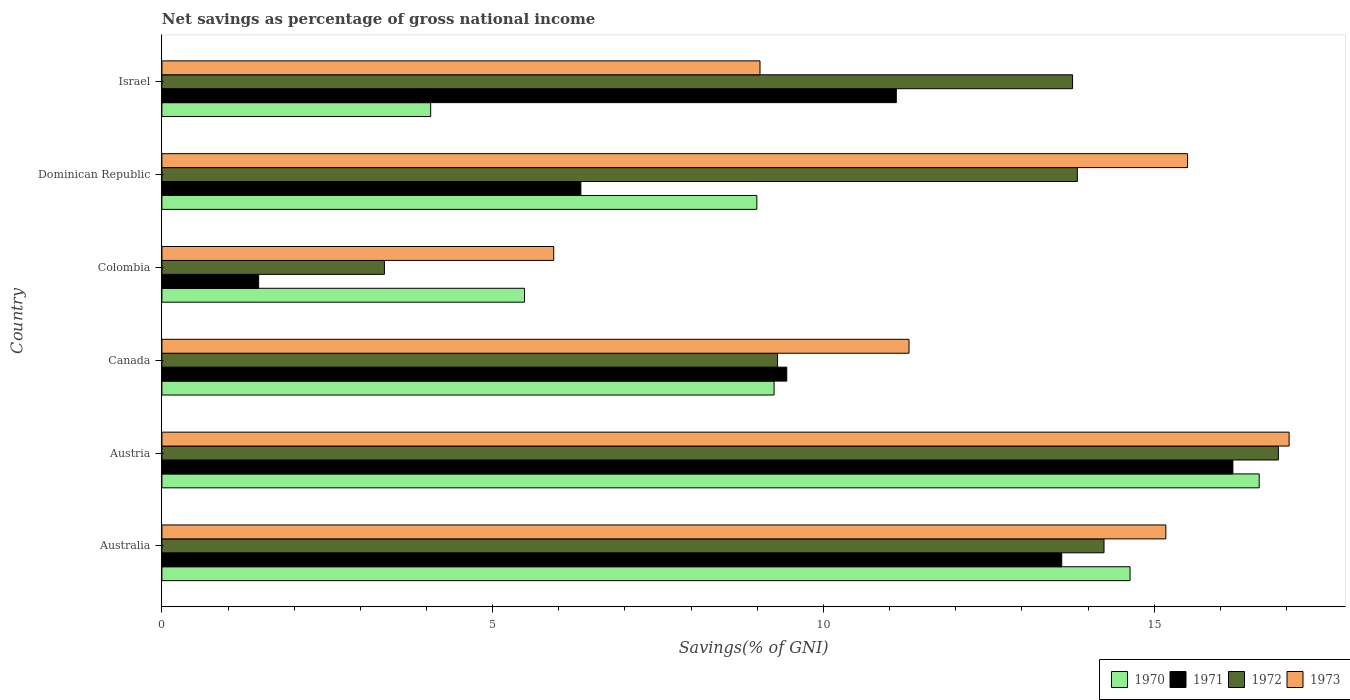Are the number of bars per tick equal to the number of legend labels?
Make the answer very short. Yes. Are the number of bars on each tick of the Y-axis equal?
Your answer should be compact. Yes. How many bars are there on the 6th tick from the top?
Your answer should be compact. 4. What is the label of the 6th group of bars from the top?
Your answer should be very brief. Australia. What is the total savings in 1970 in Dominican Republic?
Provide a succinct answer. 8.99. Across all countries, what is the maximum total savings in 1973?
Provide a succinct answer. 17.04. Across all countries, what is the minimum total savings in 1971?
Keep it short and to the point. 1.46. In which country was the total savings in 1970 minimum?
Offer a very short reply. Israel. What is the total total savings in 1970 in the graph?
Keep it short and to the point. 59.01. What is the difference between the total savings in 1970 in Canada and that in Israel?
Give a very brief answer. 5.19. What is the difference between the total savings in 1973 in Austria and the total savings in 1972 in Australia?
Make the answer very short. 2.8. What is the average total savings in 1970 per country?
Offer a terse response. 9.84. What is the difference between the total savings in 1972 and total savings in 1971 in Canada?
Keep it short and to the point. -0.14. In how many countries, is the total savings in 1973 greater than 6 %?
Ensure brevity in your answer.  5. What is the ratio of the total savings in 1970 in Austria to that in Colombia?
Keep it short and to the point. 3.03. Is the difference between the total savings in 1972 in Colombia and Dominican Republic greater than the difference between the total savings in 1971 in Colombia and Dominican Republic?
Ensure brevity in your answer.  No. What is the difference between the highest and the second highest total savings in 1971?
Provide a succinct answer. 2.59. What is the difference between the highest and the lowest total savings in 1971?
Offer a very short reply. 14.73. In how many countries, is the total savings in 1970 greater than the average total savings in 1970 taken over all countries?
Provide a succinct answer. 2. Is it the case that in every country, the sum of the total savings in 1970 and total savings in 1972 is greater than the sum of total savings in 1971 and total savings in 1973?
Give a very brief answer. Yes. What does the 3rd bar from the top in Dominican Republic represents?
Provide a short and direct response. 1971. What does the 3rd bar from the bottom in Israel represents?
Offer a very short reply. 1972. Are all the bars in the graph horizontal?
Ensure brevity in your answer.  Yes. Are the values on the major ticks of X-axis written in scientific E-notation?
Make the answer very short. No. Where does the legend appear in the graph?
Offer a terse response. Bottom right. How are the legend labels stacked?
Offer a very short reply. Horizontal. What is the title of the graph?
Give a very brief answer. Net savings as percentage of gross national income. Does "1993" appear as one of the legend labels in the graph?
Keep it short and to the point. No. What is the label or title of the X-axis?
Your answer should be compact. Savings(% of GNI). What is the Savings(% of GNI) in 1970 in Australia?
Your response must be concise. 14.63. What is the Savings(% of GNI) in 1971 in Australia?
Keep it short and to the point. 13.6. What is the Savings(% of GNI) in 1972 in Australia?
Make the answer very short. 14.24. What is the Savings(% of GNI) in 1973 in Australia?
Offer a terse response. 15.18. What is the Savings(% of GNI) in 1970 in Austria?
Provide a succinct answer. 16.59. What is the Savings(% of GNI) of 1971 in Austria?
Provide a short and direct response. 16.19. What is the Savings(% of GNI) in 1972 in Austria?
Your answer should be compact. 16.88. What is the Savings(% of GNI) in 1973 in Austria?
Your answer should be compact. 17.04. What is the Savings(% of GNI) of 1970 in Canada?
Make the answer very short. 9.25. What is the Savings(% of GNI) in 1971 in Canada?
Your response must be concise. 9.45. What is the Savings(% of GNI) in 1972 in Canada?
Your answer should be very brief. 9.31. What is the Savings(% of GNI) of 1973 in Canada?
Provide a succinct answer. 11.29. What is the Savings(% of GNI) of 1970 in Colombia?
Offer a very short reply. 5.48. What is the Savings(% of GNI) of 1971 in Colombia?
Ensure brevity in your answer.  1.46. What is the Savings(% of GNI) in 1972 in Colombia?
Provide a short and direct response. 3.36. What is the Savings(% of GNI) of 1973 in Colombia?
Offer a very short reply. 5.92. What is the Savings(% of GNI) of 1970 in Dominican Republic?
Offer a very short reply. 8.99. What is the Savings(% of GNI) of 1971 in Dominican Republic?
Keep it short and to the point. 6.33. What is the Savings(% of GNI) of 1972 in Dominican Republic?
Provide a succinct answer. 13.84. What is the Savings(% of GNI) of 1973 in Dominican Republic?
Keep it short and to the point. 15.5. What is the Savings(% of GNI) of 1970 in Israel?
Your answer should be compact. 4.06. What is the Savings(% of GNI) in 1971 in Israel?
Keep it short and to the point. 11.1. What is the Savings(% of GNI) of 1972 in Israel?
Make the answer very short. 13.77. What is the Savings(% of GNI) of 1973 in Israel?
Your answer should be compact. 9.04. Across all countries, what is the maximum Savings(% of GNI) in 1970?
Ensure brevity in your answer.  16.59. Across all countries, what is the maximum Savings(% of GNI) in 1971?
Offer a very short reply. 16.19. Across all countries, what is the maximum Savings(% of GNI) in 1972?
Offer a very short reply. 16.88. Across all countries, what is the maximum Savings(% of GNI) of 1973?
Your answer should be very brief. 17.04. Across all countries, what is the minimum Savings(% of GNI) in 1970?
Provide a succinct answer. 4.06. Across all countries, what is the minimum Savings(% of GNI) in 1971?
Ensure brevity in your answer.  1.46. Across all countries, what is the minimum Savings(% of GNI) in 1972?
Keep it short and to the point. 3.36. Across all countries, what is the minimum Savings(% of GNI) in 1973?
Offer a very short reply. 5.92. What is the total Savings(% of GNI) in 1970 in the graph?
Provide a short and direct response. 59.01. What is the total Savings(% of GNI) in 1971 in the graph?
Your answer should be compact. 58.14. What is the total Savings(% of GNI) in 1972 in the graph?
Ensure brevity in your answer.  71.39. What is the total Savings(% of GNI) in 1973 in the graph?
Give a very brief answer. 73.98. What is the difference between the Savings(% of GNI) of 1970 in Australia and that in Austria?
Provide a short and direct response. -1.95. What is the difference between the Savings(% of GNI) in 1971 in Australia and that in Austria?
Make the answer very short. -2.59. What is the difference between the Savings(% of GNI) in 1972 in Australia and that in Austria?
Make the answer very short. -2.64. What is the difference between the Savings(% of GNI) of 1973 in Australia and that in Austria?
Keep it short and to the point. -1.86. What is the difference between the Savings(% of GNI) in 1970 in Australia and that in Canada?
Offer a terse response. 5.38. What is the difference between the Savings(% of GNI) of 1971 in Australia and that in Canada?
Make the answer very short. 4.16. What is the difference between the Savings(% of GNI) in 1972 in Australia and that in Canada?
Your answer should be very brief. 4.93. What is the difference between the Savings(% of GNI) of 1973 in Australia and that in Canada?
Your answer should be compact. 3.88. What is the difference between the Savings(% of GNI) of 1970 in Australia and that in Colombia?
Offer a terse response. 9.15. What is the difference between the Savings(% of GNI) in 1971 in Australia and that in Colombia?
Provide a short and direct response. 12.14. What is the difference between the Savings(% of GNI) in 1972 in Australia and that in Colombia?
Offer a very short reply. 10.88. What is the difference between the Savings(% of GNI) in 1973 in Australia and that in Colombia?
Offer a terse response. 9.25. What is the difference between the Savings(% of GNI) of 1970 in Australia and that in Dominican Republic?
Offer a terse response. 5.64. What is the difference between the Savings(% of GNI) in 1971 in Australia and that in Dominican Republic?
Offer a very short reply. 7.27. What is the difference between the Savings(% of GNI) of 1972 in Australia and that in Dominican Republic?
Ensure brevity in your answer.  0.4. What is the difference between the Savings(% of GNI) of 1973 in Australia and that in Dominican Republic?
Your response must be concise. -0.33. What is the difference between the Savings(% of GNI) in 1970 in Australia and that in Israel?
Keep it short and to the point. 10.57. What is the difference between the Savings(% of GNI) in 1971 in Australia and that in Israel?
Provide a succinct answer. 2.5. What is the difference between the Savings(% of GNI) in 1972 in Australia and that in Israel?
Ensure brevity in your answer.  0.48. What is the difference between the Savings(% of GNI) of 1973 in Australia and that in Israel?
Provide a succinct answer. 6.14. What is the difference between the Savings(% of GNI) in 1970 in Austria and that in Canada?
Offer a terse response. 7.33. What is the difference between the Savings(% of GNI) in 1971 in Austria and that in Canada?
Give a very brief answer. 6.74. What is the difference between the Savings(% of GNI) of 1972 in Austria and that in Canada?
Make the answer very short. 7.57. What is the difference between the Savings(% of GNI) of 1973 in Austria and that in Canada?
Your answer should be very brief. 5.75. What is the difference between the Savings(% of GNI) of 1970 in Austria and that in Colombia?
Give a very brief answer. 11.11. What is the difference between the Savings(% of GNI) in 1971 in Austria and that in Colombia?
Ensure brevity in your answer.  14.73. What is the difference between the Savings(% of GNI) of 1972 in Austria and that in Colombia?
Your answer should be compact. 13.51. What is the difference between the Savings(% of GNI) of 1973 in Austria and that in Colombia?
Provide a succinct answer. 11.12. What is the difference between the Savings(% of GNI) of 1970 in Austria and that in Dominican Republic?
Keep it short and to the point. 7.59. What is the difference between the Savings(% of GNI) in 1971 in Austria and that in Dominican Republic?
Give a very brief answer. 9.86. What is the difference between the Savings(% of GNI) in 1972 in Austria and that in Dominican Republic?
Make the answer very short. 3.04. What is the difference between the Savings(% of GNI) in 1973 in Austria and that in Dominican Republic?
Offer a terse response. 1.54. What is the difference between the Savings(% of GNI) in 1970 in Austria and that in Israel?
Provide a short and direct response. 12.52. What is the difference between the Savings(% of GNI) of 1971 in Austria and that in Israel?
Keep it short and to the point. 5.09. What is the difference between the Savings(% of GNI) of 1972 in Austria and that in Israel?
Give a very brief answer. 3.11. What is the difference between the Savings(% of GNI) of 1973 in Austria and that in Israel?
Give a very brief answer. 8. What is the difference between the Savings(% of GNI) in 1970 in Canada and that in Colombia?
Ensure brevity in your answer.  3.77. What is the difference between the Savings(% of GNI) of 1971 in Canada and that in Colombia?
Offer a very short reply. 7.98. What is the difference between the Savings(% of GNI) of 1972 in Canada and that in Colombia?
Ensure brevity in your answer.  5.94. What is the difference between the Savings(% of GNI) in 1973 in Canada and that in Colombia?
Ensure brevity in your answer.  5.37. What is the difference between the Savings(% of GNI) of 1970 in Canada and that in Dominican Republic?
Provide a short and direct response. 0.26. What is the difference between the Savings(% of GNI) of 1971 in Canada and that in Dominican Republic?
Provide a short and direct response. 3.11. What is the difference between the Savings(% of GNI) in 1972 in Canada and that in Dominican Republic?
Your answer should be compact. -4.53. What is the difference between the Savings(% of GNI) of 1973 in Canada and that in Dominican Republic?
Ensure brevity in your answer.  -4.21. What is the difference between the Savings(% of GNI) in 1970 in Canada and that in Israel?
Offer a very short reply. 5.19. What is the difference between the Savings(% of GNI) of 1971 in Canada and that in Israel?
Provide a succinct answer. -1.66. What is the difference between the Savings(% of GNI) of 1972 in Canada and that in Israel?
Offer a very short reply. -4.46. What is the difference between the Savings(% of GNI) in 1973 in Canada and that in Israel?
Offer a terse response. 2.25. What is the difference between the Savings(% of GNI) of 1970 in Colombia and that in Dominican Republic?
Keep it short and to the point. -3.51. What is the difference between the Savings(% of GNI) in 1971 in Colombia and that in Dominican Republic?
Offer a very short reply. -4.87. What is the difference between the Savings(% of GNI) of 1972 in Colombia and that in Dominican Republic?
Your answer should be very brief. -10.47. What is the difference between the Savings(% of GNI) of 1973 in Colombia and that in Dominican Republic?
Your response must be concise. -9.58. What is the difference between the Savings(% of GNI) in 1970 in Colombia and that in Israel?
Ensure brevity in your answer.  1.42. What is the difference between the Savings(% of GNI) in 1971 in Colombia and that in Israel?
Make the answer very short. -9.64. What is the difference between the Savings(% of GNI) in 1972 in Colombia and that in Israel?
Provide a succinct answer. -10.4. What is the difference between the Savings(% of GNI) of 1973 in Colombia and that in Israel?
Make the answer very short. -3.12. What is the difference between the Savings(% of GNI) in 1970 in Dominican Republic and that in Israel?
Make the answer very short. 4.93. What is the difference between the Savings(% of GNI) of 1971 in Dominican Republic and that in Israel?
Keep it short and to the point. -4.77. What is the difference between the Savings(% of GNI) of 1972 in Dominican Republic and that in Israel?
Your answer should be very brief. 0.07. What is the difference between the Savings(% of GNI) of 1973 in Dominican Republic and that in Israel?
Give a very brief answer. 6.46. What is the difference between the Savings(% of GNI) in 1970 in Australia and the Savings(% of GNI) in 1971 in Austria?
Your answer should be very brief. -1.55. What is the difference between the Savings(% of GNI) in 1970 in Australia and the Savings(% of GNI) in 1972 in Austria?
Give a very brief answer. -2.24. What is the difference between the Savings(% of GNI) in 1970 in Australia and the Savings(% of GNI) in 1973 in Austria?
Provide a succinct answer. -2.4. What is the difference between the Savings(% of GNI) in 1971 in Australia and the Savings(% of GNI) in 1972 in Austria?
Make the answer very short. -3.27. What is the difference between the Savings(% of GNI) of 1971 in Australia and the Savings(% of GNI) of 1973 in Austria?
Offer a very short reply. -3.44. What is the difference between the Savings(% of GNI) in 1972 in Australia and the Savings(% of GNI) in 1973 in Austria?
Keep it short and to the point. -2.8. What is the difference between the Savings(% of GNI) in 1970 in Australia and the Savings(% of GNI) in 1971 in Canada?
Your answer should be very brief. 5.19. What is the difference between the Savings(% of GNI) in 1970 in Australia and the Savings(% of GNI) in 1972 in Canada?
Your answer should be very brief. 5.33. What is the difference between the Savings(% of GNI) of 1970 in Australia and the Savings(% of GNI) of 1973 in Canada?
Provide a succinct answer. 3.34. What is the difference between the Savings(% of GNI) of 1971 in Australia and the Savings(% of GNI) of 1972 in Canada?
Make the answer very short. 4.3. What is the difference between the Savings(% of GNI) in 1971 in Australia and the Savings(% of GNI) in 1973 in Canada?
Provide a short and direct response. 2.31. What is the difference between the Savings(% of GNI) of 1972 in Australia and the Savings(% of GNI) of 1973 in Canada?
Provide a succinct answer. 2.95. What is the difference between the Savings(% of GNI) in 1970 in Australia and the Savings(% of GNI) in 1971 in Colombia?
Make the answer very short. 13.17. What is the difference between the Savings(% of GNI) of 1970 in Australia and the Savings(% of GNI) of 1972 in Colombia?
Offer a terse response. 11.27. What is the difference between the Savings(% of GNI) in 1970 in Australia and the Savings(% of GNI) in 1973 in Colombia?
Make the answer very short. 8.71. What is the difference between the Savings(% of GNI) in 1971 in Australia and the Savings(% of GNI) in 1972 in Colombia?
Provide a short and direct response. 10.24. What is the difference between the Savings(% of GNI) of 1971 in Australia and the Savings(% of GNI) of 1973 in Colombia?
Offer a terse response. 7.68. What is the difference between the Savings(% of GNI) in 1972 in Australia and the Savings(% of GNI) in 1973 in Colombia?
Provide a succinct answer. 8.32. What is the difference between the Savings(% of GNI) of 1970 in Australia and the Savings(% of GNI) of 1971 in Dominican Republic?
Your answer should be compact. 8.3. What is the difference between the Savings(% of GNI) in 1970 in Australia and the Savings(% of GNI) in 1972 in Dominican Republic?
Give a very brief answer. 0.8. What is the difference between the Savings(% of GNI) in 1970 in Australia and the Savings(% of GNI) in 1973 in Dominican Republic?
Offer a terse response. -0.87. What is the difference between the Savings(% of GNI) of 1971 in Australia and the Savings(% of GNI) of 1972 in Dominican Republic?
Provide a succinct answer. -0.24. What is the difference between the Savings(% of GNI) of 1971 in Australia and the Savings(% of GNI) of 1973 in Dominican Republic?
Give a very brief answer. -1.9. What is the difference between the Savings(% of GNI) in 1972 in Australia and the Savings(% of GNI) in 1973 in Dominican Republic?
Your answer should be compact. -1.26. What is the difference between the Savings(% of GNI) of 1970 in Australia and the Savings(% of GNI) of 1971 in Israel?
Provide a succinct answer. 3.53. What is the difference between the Savings(% of GNI) of 1970 in Australia and the Savings(% of GNI) of 1972 in Israel?
Your answer should be very brief. 0.87. What is the difference between the Savings(% of GNI) in 1970 in Australia and the Savings(% of GNI) in 1973 in Israel?
Provide a succinct answer. 5.59. What is the difference between the Savings(% of GNI) of 1971 in Australia and the Savings(% of GNI) of 1972 in Israel?
Make the answer very short. -0.16. What is the difference between the Savings(% of GNI) of 1971 in Australia and the Savings(% of GNI) of 1973 in Israel?
Your answer should be very brief. 4.56. What is the difference between the Savings(% of GNI) of 1972 in Australia and the Savings(% of GNI) of 1973 in Israel?
Offer a very short reply. 5.2. What is the difference between the Savings(% of GNI) in 1970 in Austria and the Savings(% of GNI) in 1971 in Canada?
Your answer should be compact. 7.14. What is the difference between the Savings(% of GNI) in 1970 in Austria and the Savings(% of GNI) in 1972 in Canada?
Offer a very short reply. 7.28. What is the difference between the Savings(% of GNI) of 1970 in Austria and the Savings(% of GNI) of 1973 in Canada?
Your answer should be compact. 5.29. What is the difference between the Savings(% of GNI) of 1971 in Austria and the Savings(% of GNI) of 1972 in Canada?
Your answer should be compact. 6.88. What is the difference between the Savings(% of GNI) of 1971 in Austria and the Savings(% of GNI) of 1973 in Canada?
Give a very brief answer. 4.9. What is the difference between the Savings(% of GNI) in 1972 in Austria and the Savings(% of GNI) in 1973 in Canada?
Your answer should be compact. 5.58. What is the difference between the Savings(% of GNI) in 1970 in Austria and the Savings(% of GNI) in 1971 in Colombia?
Provide a succinct answer. 15.12. What is the difference between the Savings(% of GNI) in 1970 in Austria and the Savings(% of GNI) in 1972 in Colombia?
Give a very brief answer. 13.22. What is the difference between the Savings(% of GNI) of 1970 in Austria and the Savings(% of GNI) of 1973 in Colombia?
Provide a succinct answer. 10.66. What is the difference between the Savings(% of GNI) of 1971 in Austria and the Savings(% of GNI) of 1972 in Colombia?
Offer a terse response. 12.83. What is the difference between the Savings(% of GNI) of 1971 in Austria and the Savings(% of GNI) of 1973 in Colombia?
Ensure brevity in your answer.  10.27. What is the difference between the Savings(% of GNI) of 1972 in Austria and the Savings(% of GNI) of 1973 in Colombia?
Your response must be concise. 10.95. What is the difference between the Savings(% of GNI) of 1970 in Austria and the Savings(% of GNI) of 1971 in Dominican Republic?
Make the answer very short. 10.25. What is the difference between the Savings(% of GNI) of 1970 in Austria and the Savings(% of GNI) of 1972 in Dominican Republic?
Provide a short and direct response. 2.75. What is the difference between the Savings(% of GNI) in 1970 in Austria and the Savings(% of GNI) in 1973 in Dominican Republic?
Your response must be concise. 1.08. What is the difference between the Savings(% of GNI) in 1971 in Austria and the Savings(% of GNI) in 1972 in Dominican Republic?
Give a very brief answer. 2.35. What is the difference between the Savings(% of GNI) in 1971 in Austria and the Savings(% of GNI) in 1973 in Dominican Republic?
Offer a very short reply. 0.69. What is the difference between the Savings(% of GNI) of 1972 in Austria and the Savings(% of GNI) of 1973 in Dominican Republic?
Make the answer very short. 1.37. What is the difference between the Savings(% of GNI) in 1970 in Austria and the Savings(% of GNI) in 1971 in Israel?
Provide a short and direct response. 5.49. What is the difference between the Savings(% of GNI) in 1970 in Austria and the Savings(% of GNI) in 1972 in Israel?
Offer a terse response. 2.82. What is the difference between the Savings(% of GNI) in 1970 in Austria and the Savings(% of GNI) in 1973 in Israel?
Offer a terse response. 7.55. What is the difference between the Savings(% of GNI) of 1971 in Austria and the Savings(% of GNI) of 1972 in Israel?
Your answer should be compact. 2.42. What is the difference between the Savings(% of GNI) of 1971 in Austria and the Savings(% of GNI) of 1973 in Israel?
Make the answer very short. 7.15. What is the difference between the Savings(% of GNI) of 1972 in Austria and the Savings(% of GNI) of 1973 in Israel?
Your answer should be very brief. 7.84. What is the difference between the Savings(% of GNI) in 1970 in Canada and the Savings(% of GNI) in 1971 in Colombia?
Ensure brevity in your answer.  7.79. What is the difference between the Savings(% of GNI) in 1970 in Canada and the Savings(% of GNI) in 1972 in Colombia?
Provide a succinct answer. 5.89. What is the difference between the Savings(% of GNI) in 1970 in Canada and the Savings(% of GNI) in 1973 in Colombia?
Offer a very short reply. 3.33. What is the difference between the Savings(% of GNI) of 1971 in Canada and the Savings(% of GNI) of 1972 in Colombia?
Make the answer very short. 6.08. What is the difference between the Savings(% of GNI) in 1971 in Canada and the Savings(% of GNI) in 1973 in Colombia?
Provide a succinct answer. 3.52. What is the difference between the Savings(% of GNI) of 1972 in Canada and the Savings(% of GNI) of 1973 in Colombia?
Offer a terse response. 3.38. What is the difference between the Savings(% of GNI) of 1970 in Canada and the Savings(% of GNI) of 1971 in Dominican Republic?
Your response must be concise. 2.92. What is the difference between the Savings(% of GNI) of 1970 in Canada and the Savings(% of GNI) of 1972 in Dominican Republic?
Keep it short and to the point. -4.58. What is the difference between the Savings(% of GNI) in 1970 in Canada and the Savings(% of GNI) in 1973 in Dominican Republic?
Provide a succinct answer. -6.25. What is the difference between the Savings(% of GNI) in 1971 in Canada and the Savings(% of GNI) in 1972 in Dominican Republic?
Ensure brevity in your answer.  -4.39. What is the difference between the Savings(% of GNI) in 1971 in Canada and the Savings(% of GNI) in 1973 in Dominican Republic?
Provide a short and direct response. -6.06. What is the difference between the Savings(% of GNI) in 1972 in Canada and the Savings(% of GNI) in 1973 in Dominican Republic?
Provide a succinct answer. -6.2. What is the difference between the Savings(% of GNI) of 1970 in Canada and the Savings(% of GNI) of 1971 in Israel?
Offer a terse response. -1.85. What is the difference between the Savings(% of GNI) in 1970 in Canada and the Savings(% of GNI) in 1972 in Israel?
Keep it short and to the point. -4.51. What is the difference between the Savings(% of GNI) in 1970 in Canada and the Savings(% of GNI) in 1973 in Israel?
Keep it short and to the point. 0.21. What is the difference between the Savings(% of GNI) of 1971 in Canada and the Savings(% of GNI) of 1972 in Israel?
Your answer should be very brief. -4.32. What is the difference between the Savings(% of GNI) in 1971 in Canada and the Savings(% of GNI) in 1973 in Israel?
Your answer should be compact. 0.4. What is the difference between the Savings(% of GNI) of 1972 in Canada and the Savings(% of GNI) of 1973 in Israel?
Ensure brevity in your answer.  0.27. What is the difference between the Savings(% of GNI) in 1970 in Colombia and the Savings(% of GNI) in 1971 in Dominican Republic?
Your answer should be very brief. -0.85. What is the difference between the Savings(% of GNI) in 1970 in Colombia and the Savings(% of GNI) in 1972 in Dominican Republic?
Offer a terse response. -8.36. What is the difference between the Savings(% of GNI) in 1970 in Colombia and the Savings(% of GNI) in 1973 in Dominican Republic?
Ensure brevity in your answer.  -10.02. What is the difference between the Savings(% of GNI) of 1971 in Colombia and the Savings(% of GNI) of 1972 in Dominican Republic?
Your answer should be compact. -12.38. What is the difference between the Savings(% of GNI) of 1971 in Colombia and the Savings(% of GNI) of 1973 in Dominican Republic?
Your answer should be very brief. -14.04. What is the difference between the Savings(% of GNI) in 1972 in Colombia and the Savings(% of GNI) in 1973 in Dominican Republic?
Your answer should be very brief. -12.14. What is the difference between the Savings(% of GNI) of 1970 in Colombia and the Savings(% of GNI) of 1971 in Israel?
Your answer should be very brief. -5.62. What is the difference between the Savings(% of GNI) of 1970 in Colombia and the Savings(% of GNI) of 1972 in Israel?
Give a very brief answer. -8.28. What is the difference between the Savings(% of GNI) of 1970 in Colombia and the Savings(% of GNI) of 1973 in Israel?
Your answer should be compact. -3.56. What is the difference between the Savings(% of GNI) of 1971 in Colombia and the Savings(% of GNI) of 1972 in Israel?
Ensure brevity in your answer.  -12.3. What is the difference between the Savings(% of GNI) of 1971 in Colombia and the Savings(% of GNI) of 1973 in Israel?
Your response must be concise. -7.58. What is the difference between the Savings(% of GNI) of 1972 in Colombia and the Savings(% of GNI) of 1973 in Israel?
Offer a very short reply. -5.68. What is the difference between the Savings(% of GNI) of 1970 in Dominican Republic and the Savings(% of GNI) of 1971 in Israel?
Provide a succinct answer. -2.11. What is the difference between the Savings(% of GNI) in 1970 in Dominican Republic and the Savings(% of GNI) in 1972 in Israel?
Give a very brief answer. -4.77. What is the difference between the Savings(% of GNI) of 1970 in Dominican Republic and the Savings(% of GNI) of 1973 in Israel?
Provide a succinct answer. -0.05. What is the difference between the Savings(% of GNI) of 1971 in Dominican Republic and the Savings(% of GNI) of 1972 in Israel?
Offer a terse response. -7.43. What is the difference between the Savings(% of GNI) of 1971 in Dominican Republic and the Savings(% of GNI) of 1973 in Israel?
Offer a terse response. -2.71. What is the difference between the Savings(% of GNI) of 1972 in Dominican Republic and the Savings(% of GNI) of 1973 in Israel?
Give a very brief answer. 4.8. What is the average Savings(% of GNI) of 1970 per country?
Give a very brief answer. 9.84. What is the average Savings(% of GNI) in 1971 per country?
Ensure brevity in your answer.  9.69. What is the average Savings(% of GNI) of 1972 per country?
Your answer should be very brief. 11.9. What is the average Savings(% of GNI) in 1973 per country?
Offer a terse response. 12.33. What is the difference between the Savings(% of GNI) in 1970 and Savings(% of GNI) in 1971 in Australia?
Provide a short and direct response. 1.03. What is the difference between the Savings(% of GNI) in 1970 and Savings(% of GNI) in 1972 in Australia?
Keep it short and to the point. 0.39. What is the difference between the Savings(% of GNI) in 1970 and Savings(% of GNI) in 1973 in Australia?
Provide a succinct answer. -0.54. What is the difference between the Savings(% of GNI) of 1971 and Savings(% of GNI) of 1972 in Australia?
Provide a short and direct response. -0.64. What is the difference between the Savings(% of GNI) in 1971 and Savings(% of GNI) in 1973 in Australia?
Your response must be concise. -1.57. What is the difference between the Savings(% of GNI) of 1972 and Savings(% of GNI) of 1973 in Australia?
Your response must be concise. -0.93. What is the difference between the Savings(% of GNI) in 1970 and Savings(% of GNI) in 1971 in Austria?
Provide a succinct answer. 0.4. What is the difference between the Savings(% of GNI) in 1970 and Savings(% of GNI) in 1972 in Austria?
Give a very brief answer. -0.29. What is the difference between the Savings(% of GNI) of 1970 and Savings(% of GNI) of 1973 in Austria?
Your answer should be very brief. -0.45. What is the difference between the Savings(% of GNI) in 1971 and Savings(% of GNI) in 1972 in Austria?
Ensure brevity in your answer.  -0.69. What is the difference between the Savings(% of GNI) in 1971 and Savings(% of GNI) in 1973 in Austria?
Provide a succinct answer. -0.85. What is the difference between the Savings(% of GNI) in 1972 and Savings(% of GNI) in 1973 in Austria?
Keep it short and to the point. -0.16. What is the difference between the Savings(% of GNI) of 1970 and Savings(% of GNI) of 1971 in Canada?
Your answer should be very brief. -0.19. What is the difference between the Savings(% of GNI) of 1970 and Savings(% of GNI) of 1972 in Canada?
Your answer should be compact. -0.05. What is the difference between the Savings(% of GNI) in 1970 and Savings(% of GNI) in 1973 in Canada?
Your response must be concise. -2.04. What is the difference between the Savings(% of GNI) in 1971 and Savings(% of GNI) in 1972 in Canada?
Your answer should be compact. 0.14. What is the difference between the Savings(% of GNI) of 1971 and Savings(% of GNI) of 1973 in Canada?
Give a very brief answer. -1.85. What is the difference between the Savings(% of GNI) of 1972 and Savings(% of GNI) of 1973 in Canada?
Your answer should be compact. -1.99. What is the difference between the Savings(% of GNI) of 1970 and Savings(% of GNI) of 1971 in Colombia?
Provide a short and direct response. 4.02. What is the difference between the Savings(% of GNI) of 1970 and Savings(% of GNI) of 1972 in Colombia?
Make the answer very short. 2.12. What is the difference between the Savings(% of GNI) in 1970 and Savings(% of GNI) in 1973 in Colombia?
Offer a very short reply. -0.44. What is the difference between the Savings(% of GNI) in 1971 and Savings(% of GNI) in 1972 in Colombia?
Offer a terse response. -1.9. What is the difference between the Savings(% of GNI) of 1971 and Savings(% of GNI) of 1973 in Colombia?
Offer a terse response. -4.46. What is the difference between the Savings(% of GNI) in 1972 and Savings(% of GNI) in 1973 in Colombia?
Provide a succinct answer. -2.56. What is the difference between the Savings(% of GNI) of 1970 and Savings(% of GNI) of 1971 in Dominican Republic?
Give a very brief answer. 2.66. What is the difference between the Savings(% of GNI) in 1970 and Savings(% of GNI) in 1972 in Dominican Republic?
Give a very brief answer. -4.84. What is the difference between the Savings(% of GNI) of 1970 and Savings(% of GNI) of 1973 in Dominican Republic?
Offer a very short reply. -6.51. What is the difference between the Savings(% of GNI) in 1971 and Savings(% of GNI) in 1972 in Dominican Republic?
Provide a short and direct response. -7.5. What is the difference between the Savings(% of GNI) of 1971 and Savings(% of GNI) of 1973 in Dominican Republic?
Provide a succinct answer. -9.17. What is the difference between the Savings(% of GNI) in 1972 and Savings(% of GNI) in 1973 in Dominican Republic?
Provide a succinct answer. -1.67. What is the difference between the Savings(% of GNI) of 1970 and Savings(% of GNI) of 1971 in Israel?
Your response must be concise. -7.04. What is the difference between the Savings(% of GNI) of 1970 and Savings(% of GNI) of 1972 in Israel?
Your response must be concise. -9.7. What is the difference between the Savings(% of GNI) of 1970 and Savings(% of GNI) of 1973 in Israel?
Provide a succinct answer. -4.98. What is the difference between the Savings(% of GNI) of 1971 and Savings(% of GNI) of 1972 in Israel?
Your answer should be compact. -2.66. What is the difference between the Savings(% of GNI) of 1971 and Savings(% of GNI) of 1973 in Israel?
Ensure brevity in your answer.  2.06. What is the difference between the Savings(% of GNI) of 1972 and Savings(% of GNI) of 1973 in Israel?
Make the answer very short. 4.73. What is the ratio of the Savings(% of GNI) of 1970 in Australia to that in Austria?
Keep it short and to the point. 0.88. What is the ratio of the Savings(% of GNI) of 1971 in Australia to that in Austria?
Provide a succinct answer. 0.84. What is the ratio of the Savings(% of GNI) of 1972 in Australia to that in Austria?
Your answer should be compact. 0.84. What is the ratio of the Savings(% of GNI) in 1973 in Australia to that in Austria?
Your answer should be compact. 0.89. What is the ratio of the Savings(% of GNI) of 1970 in Australia to that in Canada?
Your response must be concise. 1.58. What is the ratio of the Savings(% of GNI) in 1971 in Australia to that in Canada?
Provide a short and direct response. 1.44. What is the ratio of the Savings(% of GNI) in 1972 in Australia to that in Canada?
Give a very brief answer. 1.53. What is the ratio of the Savings(% of GNI) in 1973 in Australia to that in Canada?
Provide a short and direct response. 1.34. What is the ratio of the Savings(% of GNI) of 1970 in Australia to that in Colombia?
Ensure brevity in your answer.  2.67. What is the ratio of the Savings(% of GNI) of 1971 in Australia to that in Colombia?
Your answer should be compact. 9.3. What is the ratio of the Savings(% of GNI) of 1972 in Australia to that in Colombia?
Keep it short and to the point. 4.23. What is the ratio of the Savings(% of GNI) of 1973 in Australia to that in Colombia?
Give a very brief answer. 2.56. What is the ratio of the Savings(% of GNI) of 1970 in Australia to that in Dominican Republic?
Provide a short and direct response. 1.63. What is the ratio of the Savings(% of GNI) of 1971 in Australia to that in Dominican Republic?
Your answer should be very brief. 2.15. What is the ratio of the Savings(% of GNI) of 1972 in Australia to that in Dominican Republic?
Your answer should be compact. 1.03. What is the ratio of the Savings(% of GNI) of 1973 in Australia to that in Dominican Republic?
Provide a short and direct response. 0.98. What is the ratio of the Savings(% of GNI) in 1970 in Australia to that in Israel?
Offer a terse response. 3.6. What is the ratio of the Savings(% of GNI) of 1971 in Australia to that in Israel?
Keep it short and to the point. 1.23. What is the ratio of the Savings(% of GNI) in 1972 in Australia to that in Israel?
Make the answer very short. 1.03. What is the ratio of the Savings(% of GNI) in 1973 in Australia to that in Israel?
Provide a succinct answer. 1.68. What is the ratio of the Savings(% of GNI) of 1970 in Austria to that in Canada?
Ensure brevity in your answer.  1.79. What is the ratio of the Savings(% of GNI) of 1971 in Austria to that in Canada?
Ensure brevity in your answer.  1.71. What is the ratio of the Savings(% of GNI) of 1972 in Austria to that in Canada?
Your answer should be compact. 1.81. What is the ratio of the Savings(% of GNI) of 1973 in Austria to that in Canada?
Give a very brief answer. 1.51. What is the ratio of the Savings(% of GNI) of 1970 in Austria to that in Colombia?
Your answer should be compact. 3.03. What is the ratio of the Savings(% of GNI) of 1971 in Austria to that in Colombia?
Give a very brief answer. 11.07. What is the ratio of the Savings(% of GNI) of 1972 in Austria to that in Colombia?
Provide a short and direct response. 5.02. What is the ratio of the Savings(% of GNI) in 1973 in Austria to that in Colombia?
Your response must be concise. 2.88. What is the ratio of the Savings(% of GNI) in 1970 in Austria to that in Dominican Republic?
Your response must be concise. 1.84. What is the ratio of the Savings(% of GNI) of 1971 in Austria to that in Dominican Republic?
Provide a short and direct response. 2.56. What is the ratio of the Savings(% of GNI) of 1972 in Austria to that in Dominican Republic?
Your response must be concise. 1.22. What is the ratio of the Savings(% of GNI) of 1973 in Austria to that in Dominican Republic?
Make the answer very short. 1.1. What is the ratio of the Savings(% of GNI) in 1970 in Austria to that in Israel?
Your answer should be very brief. 4.08. What is the ratio of the Savings(% of GNI) of 1971 in Austria to that in Israel?
Ensure brevity in your answer.  1.46. What is the ratio of the Savings(% of GNI) of 1972 in Austria to that in Israel?
Your response must be concise. 1.23. What is the ratio of the Savings(% of GNI) of 1973 in Austria to that in Israel?
Ensure brevity in your answer.  1.88. What is the ratio of the Savings(% of GNI) of 1970 in Canada to that in Colombia?
Your answer should be very brief. 1.69. What is the ratio of the Savings(% of GNI) in 1971 in Canada to that in Colombia?
Ensure brevity in your answer.  6.46. What is the ratio of the Savings(% of GNI) in 1972 in Canada to that in Colombia?
Ensure brevity in your answer.  2.77. What is the ratio of the Savings(% of GNI) of 1973 in Canada to that in Colombia?
Offer a very short reply. 1.91. What is the ratio of the Savings(% of GNI) in 1971 in Canada to that in Dominican Republic?
Keep it short and to the point. 1.49. What is the ratio of the Savings(% of GNI) in 1972 in Canada to that in Dominican Republic?
Ensure brevity in your answer.  0.67. What is the ratio of the Savings(% of GNI) in 1973 in Canada to that in Dominican Republic?
Provide a succinct answer. 0.73. What is the ratio of the Savings(% of GNI) of 1970 in Canada to that in Israel?
Provide a succinct answer. 2.28. What is the ratio of the Savings(% of GNI) in 1971 in Canada to that in Israel?
Your answer should be compact. 0.85. What is the ratio of the Savings(% of GNI) of 1972 in Canada to that in Israel?
Keep it short and to the point. 0.68. What is the ratio of the Savings(% of GNI) of 1973 in Canada to that in Israel?
Provide a short and direct response. 1.25. What is the ratio of the Savings(% of GNI) in 1970 in Colombia to that in Dominican Republic?
Make the answer very short. 0.61. What is the ratio of the Savings(% of GNI) in 1971 in Colombia to that in Dominican Republic?
Your response must be concise. 0.23. What is the ratio of the Savings(% of GNI) in 1972 in Colombia to that in Dominican Republic?
Provide a short and direct response. 0.24. What is the ratio of the Savings(% of GNI) in 1973 in Colombia to that in Dominican Republic?
Offer a very short reply. 0.38. What is the ratio of the Savings(% of GNI) of 1970 in Colombia to that in Israel?
Your response must be concise. 1.35. What is the ratio of the Savings(% of GNI) in 1971 in Colombia to that in Israel?
Your answer should be compact. 0.13. What is the ratio of the Savings(% of GNI) in 1972 in Colombia to that in Israel?
Give a very brief answer. 0.24. What is the ratio of the Savings(% of GNI) in 1973 in Colombia to that in Israel?
Keep it short and to the point. 0.66. What is the ratio of the Savings(% of GNI) of 1970 in Dominican Republic to that in Israel?
Make the answer very short. 2.21. What is the ratio of the Savings(% of GNI) in 1971 in Dominican Republic to that in Israel?
Ensure brevity in your answer.  0.57. What is the ratio of the Savings(% of GNI) in 1972 in Dominican Republic to that in Israel?
Offer a terse response. 1.01. What is the ratio of the Savings(% of GNI) in 1973 in Dominican Republic to that in Israel?
Your answer should be compact. 1.71. What is the difference between the highest and the second highest Savings(% of GNI) of 1970?
Provide a succinct answer. 1.95. What is the difference between the highest and the second highest Savings(% of GNI) of 1971?
Offer a terse response. 2.59. What is the difference between the highest and the second highest Savings(% of GNI) of 1972?
Ensure brevity in your answer.  2.64. What is the difference between the highest and the second highest Savings(% of GNI) in 1973?
Ensure brevity in your answer.  1.54. What is the difference between the highest and the lowest Savings(% of GNI) of 1970?
Give a very brief answer. 12.52. What is the difference between the highest and the lowest Savings(% of GNI) in 1971?
Make the answer very short. 14.73. What is the difference between the highest and the lowest Savings(% of GNI) in 1972?
Provide a short and direct response. 13.51. What is the difference between the highest and the lowest Savings(% of GNI) in 1973?
Your answer should be very brief. 11.12. 